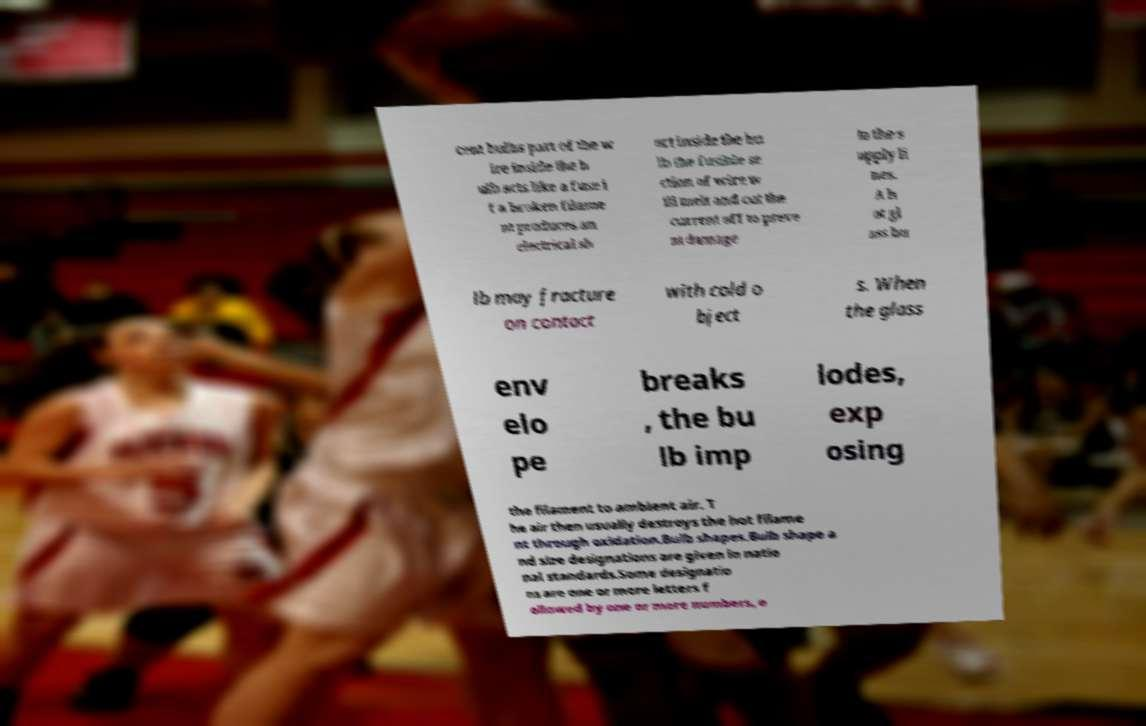Could you extract and type out the text from this image? cent bulbs part of the w ire inside the b ulb acts like a fuse i f a broken filame nt produces an electrical sh ort inside the bu lb the fusible se ction of wire w ill melt and cut the current off to preve nt damage to the s upply li nes. A h ot gl ass bu lb may fracture on contact with cold o bject s. When the glass env elo pe breaks , the bu lb imp lodes, exp osing the filament to ambient air. T he air then usually destroys the hot filame nt through oxidation.Bulb shapes.Bulb shape a nd size designations are given in natio nal standards.Some designatio ns are one or more letters f ollowed by one or more numbers, e 